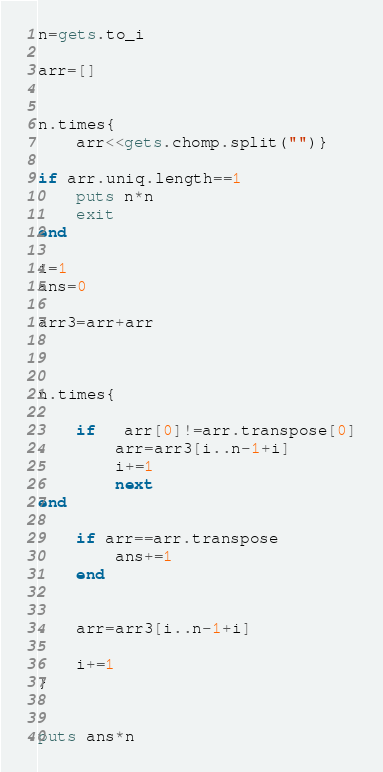<code> <loc_0><loc_0><loc_500><loc_500><_Ruby_>n=gets.to_i
 
arr=[]
 
 
n.times{
    arr<<gets.chomp.split("")}
    
if arr.uniq.length==1
    puts n*n
    exit
end
    
i=1
ans=0
 
arr3=arr+arr
 
 
 
n.times{
    
    if   arr[0]!=arr.transpose[0]
        arr=arr3[i..n-1+i]
        i+=1
        next
end
    
    if arr==arr.transpose
        ans+=1
    end
    
    
    arr=arr3[i..n-1+i]
    
    i+=1
}
    
    
puts ans*n</code> 